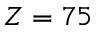<formula> <loc_0><loc_0><loc_500><loc_500>Z = 7 5</formula> 